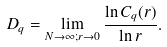<formula> <loc_0><loc_0><loc_500><loc_500>D _ { q } = \lim _ { N \to \infty ; r \to 0 } \frac { \ln C _ { q } ( r ) } { \ln r } .</formula> 